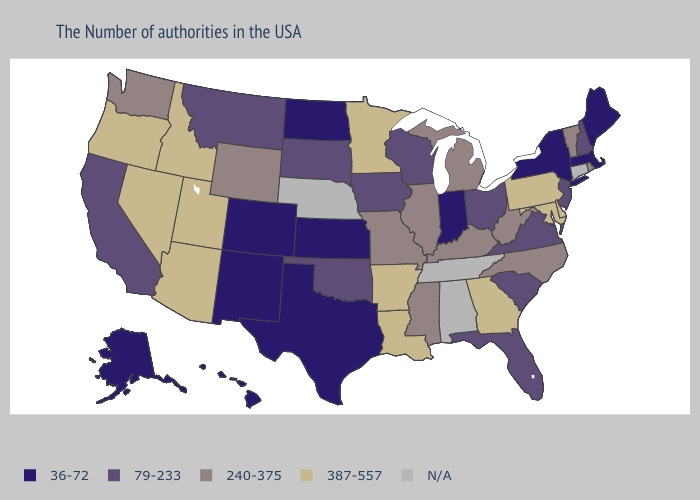Name the states that have a value in the range 79-233?
Be succinct. New Hampshire, New Jersey, Virginia, South Carolina, Ohio, Florida, Wisconsin, Iowa, Oklahoma, South Dakota, Montana, California. Does New York have the highest value in the Northeast?
Give a very brief answer. No. What is the value of Idaho?
Write a very short answer. 387-557. Name the states that have a value in the range 79-233?
Write a very short answer. New Hampshire, New Jersey, Virginia, South Carolina, Ohio, Florida, Wisconsin, Iowa, Oklahoma, South Dakota, Montana, California. Does Massachusetts have the lowest value in the USA?
Quick response, please. Yes. Name the states that have a value in the range 387-557?
Keep it brief. Delaware, Maryland, Pennsylvania, Georgia, Louisiana, Arkansas, Minnesota, Utah, Arizona, Idaho, Nevada, Oregon. How many symbols are there in the legend?
Answer briefly. 5. What is the lowest value in the West?
Quick response, please. 36-72. Which states have the lowest value in the Northeast?
Write a very short answer. Maine, Massachusetts, New York. Among the states that border Idaho , which have the lowest value?
Answer briefly. Montana. What is the value of Mississippi?
Keep it brief. 240-375. Which states hav the highest value in the West?
Be succinct. Utah, Arizona, Idaho, Nevada, Oregon. What is the highest value in the West ?
Answer briefly. 387-557. What is the lowest value in the USA?
Answer briefly. 36-72. 